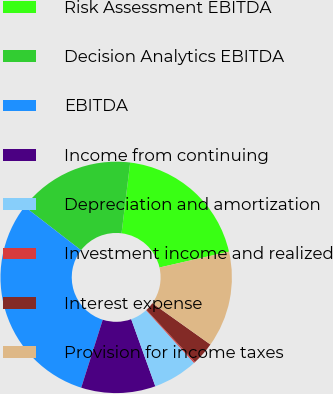<chart> <loc_0><loc_0><loc_500><loc_500><pie_chart><fcel>Risk Assessment EBITDA<fcel>Decision Analytics EBITDA<fcel>EBITDA<fcel>Income from continuing<fcel>Depreciation and amortization<fcel>Investment income and realized<fcel>Interest expense<fcel>Provision for income taxes<nl><fcel>19.5%<fcel>16.46%<fcel>30.59%<fcel>10.38%<fcel>6.26%<fcel>0.18%<fcel>3.22%<fcel>13.42%<nl></chart> 